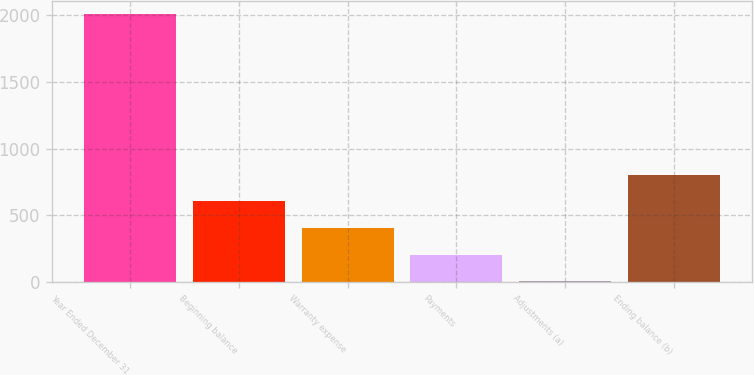<chart> <loc_0><loc_0><loc_500><loc_500><bar_chart><fcel>Year Ended December 31<fcel>Beginning balance<fcel>Warranty expense<fcel>Payments<fcel>Adjustments (a)<fcel>Ending balance (b)<nl><fcel>2006<fcel>606<fcel>406<fcel>206<fcel>6<fcel>806<nl></chart> 